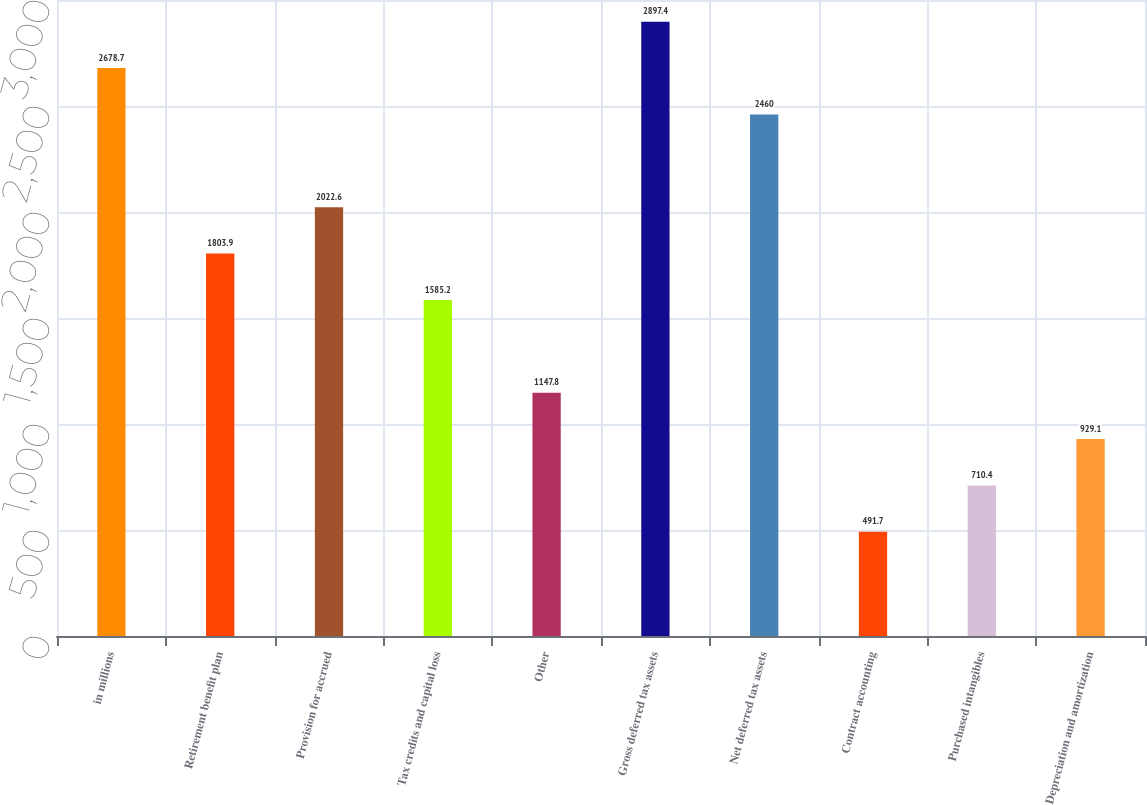<chart> <loc_0><loc_0><loc_500><loc_500><bar_chart><fcel>in millions<fcel>Retirement benefit plan<fcel>Provision for accrued<fcel>Tax credits and capital loss<fcel>Other<fcel>Gross deferred tax assets<fcel>Net deferred tax assets<fcel>Contract accounting<fcel>Purchased intangibles<fcel>Depreciation and amortization<nl><fcel>2678.7<fcel>1803.9<fcel>2022.6<fcel>1585.2<fcel>1147.8<fcel>2897.4<fcel>2460<fcel>491.7<fcel>710.4<fcel>929.1<nl></chart> 